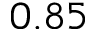Convert formula to latex. <formula><loc_0><loc_0><loc_500><loc_500>0 . 8 5</formula> 